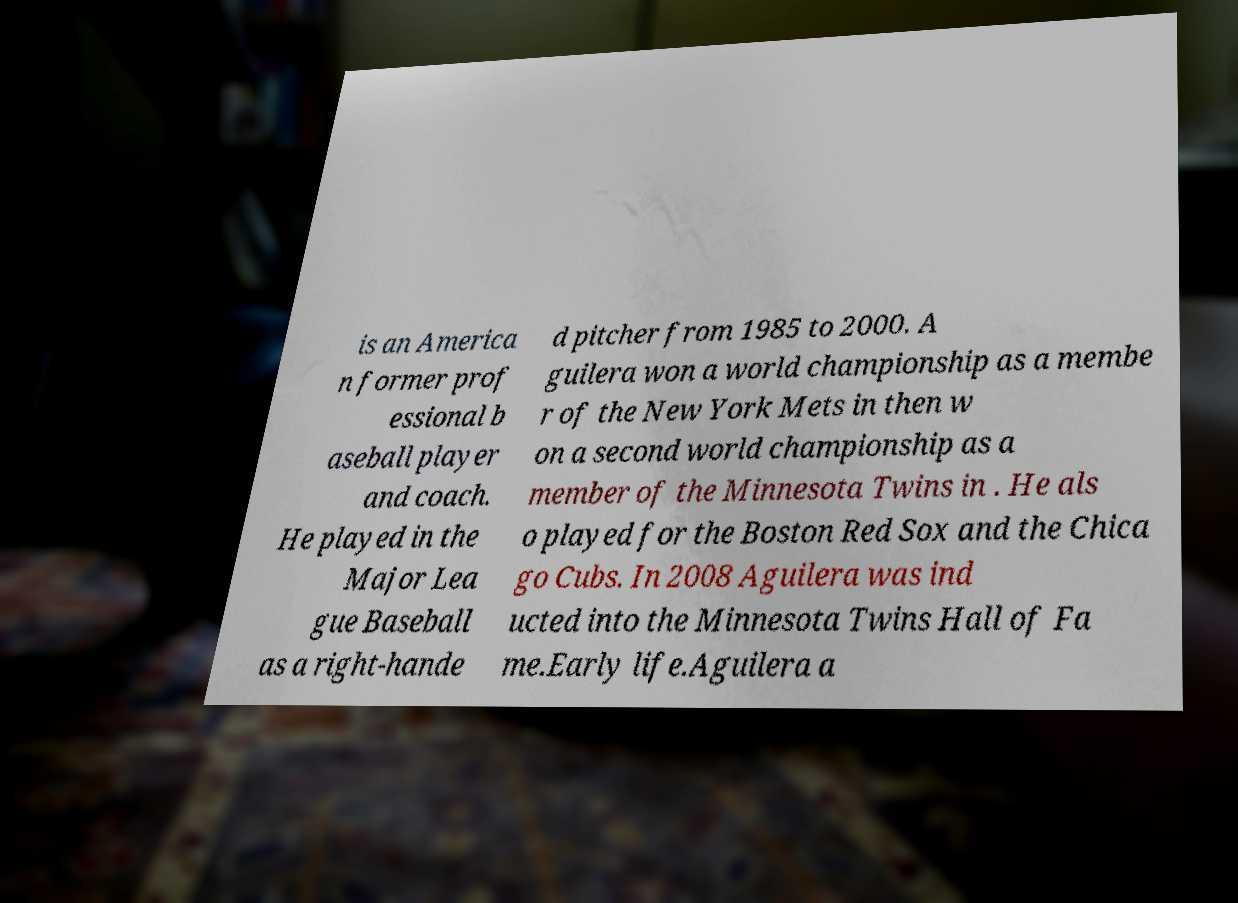What messages or text are displayed in this image? I need them in a readable, typed format. is an America n former prof essional b aseball player and coach. He played in the Major Lea gue Baseball as a right-hande d pitcher from 1985 to 2000. A guilera won a world championship as a membe r of the New York Mets in then w on a second world championship as a member of the Minnesota Twins in . He als o played for the Boston Red Sox and the Chica go Cubs. In 2008 Aguilera was ind ucted into the Minnesota Twins Hall of Fa me.Early life.Aguilera a 